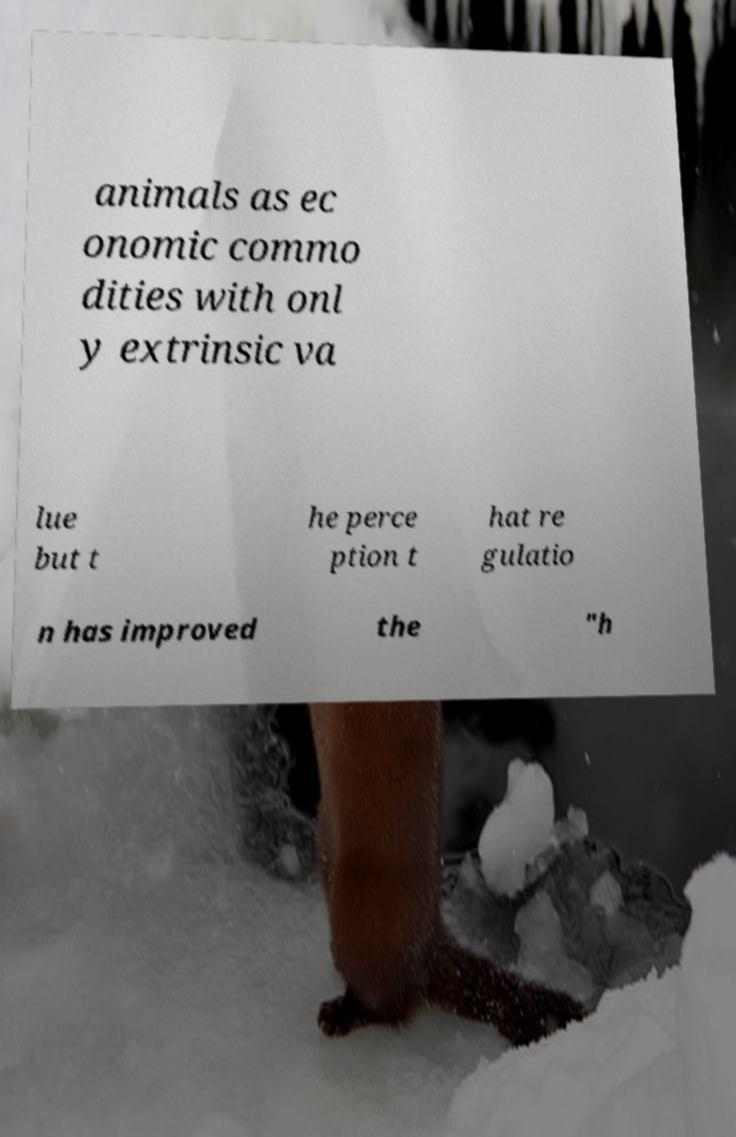Please read and relay the text visible in this image. What does it say? animals as ec onomic commo dities with onl y extrinsic va lue but t he perce ption t hat re gulatio n has improved the "h 